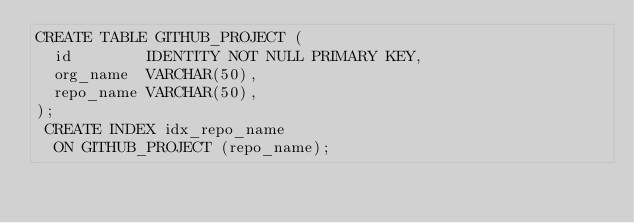<code> <loc_0><loc_0><loc_500><loc_500><_SQL_>CREATE TABLE GITHUB_PROJECT (
  id        IDENTITY NOT NULL PRIMARY KEY,
  org_name  VARCHAR(50),
  repo_name VARCHAR(50),
);
 CREATE INDEX idx_repo_name
  ON GITHUB_PROJECT (repo_name);</code> 